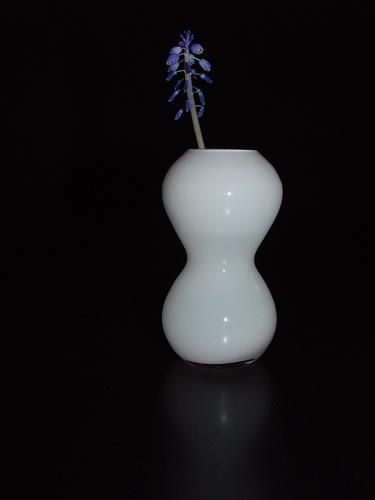Who do these items probably belong to?
Concise answer only. Woman. The vase resembles the silhouette of which number?
Quick response, please. 8. Is the flower dead?
Keep it brief. No. How many different vases are there?
Give a very brief answer. 1. Is one of the items casting a shadow?
Write a very short answer. No. What color is the vase?
Answer briefly. White. Do the flowers and the vase match?
Give a very brief answer. No. How many items are in this photo?
Give a very brief answer. 2. What is in the vase?
Concise answer only. Flower. What is the background color in this image?
Short answer required. Black. What color is the bottle?
Concise answer only. White. What type of vase is it?
Short answer required. Hourglass. Is the container about half full?
Concise answer only. No. Are the purple flowers laying on the right side or left side of the bottle?
Concise answer only. Left. How many purple flowers are in there?
Answer briefly. 1. Are there flowers in the vase?
Keep it brief. Yes. What is the purpose of the blue and white item on the right?
Quick response, please. Vase. What is on the table?
Be succinct. Vase. How many vases are there?
Short answer required. 1. What pattern does the vase have?
Keep it brief. None. Which object has a pineapple on it?
Give a very brief answer. None. Is this pretty?
Keep it brief. Yes. What figure is inside the globe?
Be succinct. Flower. Is this vase full of flowers?
Short answer required. No. What color is the backdrop?
Answer briefly. Black. What color are the flowers?
Answer briefly. Purple. 